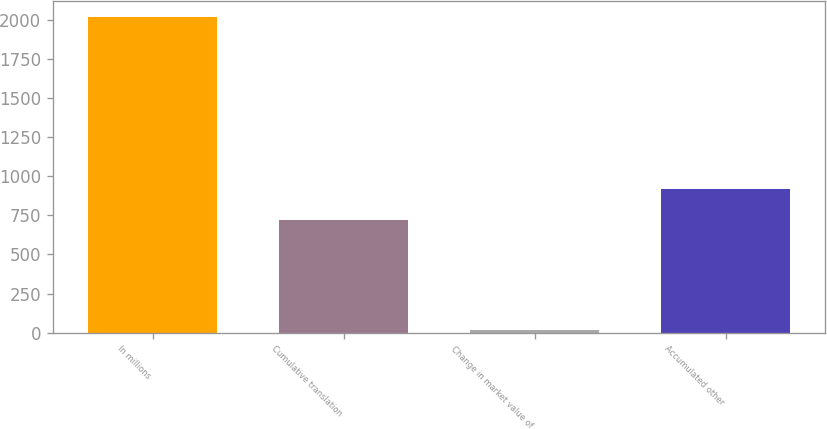<chart> <loc_0><loc_0><loc_500><loc_500><bar_chart><fcel>In millions<fcel>Cumulative translation<fcel>Change in market value of<fcel>Accumulated other<nl><fcel>2016<fcel>718.9<fcel>17.4<fcel>918.76<nl></chart> 